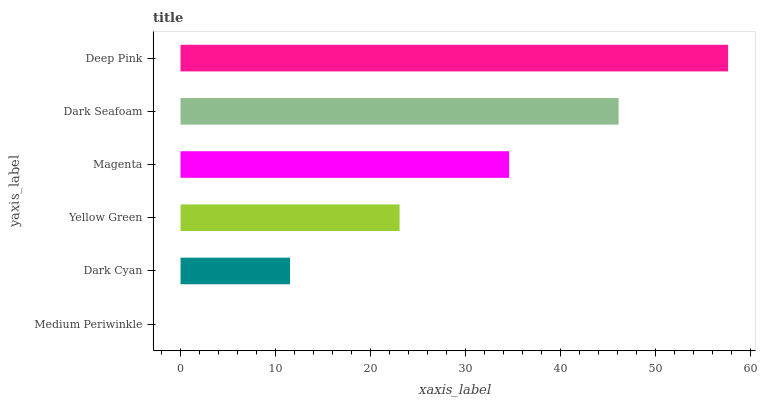Is Medium Periwinkle the minimum?
Answer yes or no. Yes. Is Deep Pink the maximum?
Answer yes or no. Yes. Is Dark Cyan the minimum?
Answer yes or no. No. Is Dark Cyan the maximum?
Answer yes or no. No. Is Dark Cyan greater than Medium Periwinkle?
Answer yes or no. Yes. Is Medium Periwinkle less than Dark Cyan?
Answer yes or no. Yes. Is Medium Periwinkle greater than Dark Cyan?
Answer yes or no. No. Is Dark Cyan less than Medium Periwinkle?
Answer yes or no. No. Is Magenta the high median?
Answer yes or no. Yes. Is Yellow Green the low median?
Answer yes or no. Yes. Is Yellow Green the high median?
Answer yes or no. No. Is Medium Periwinkle the low median?
Answer yes or no. No. 